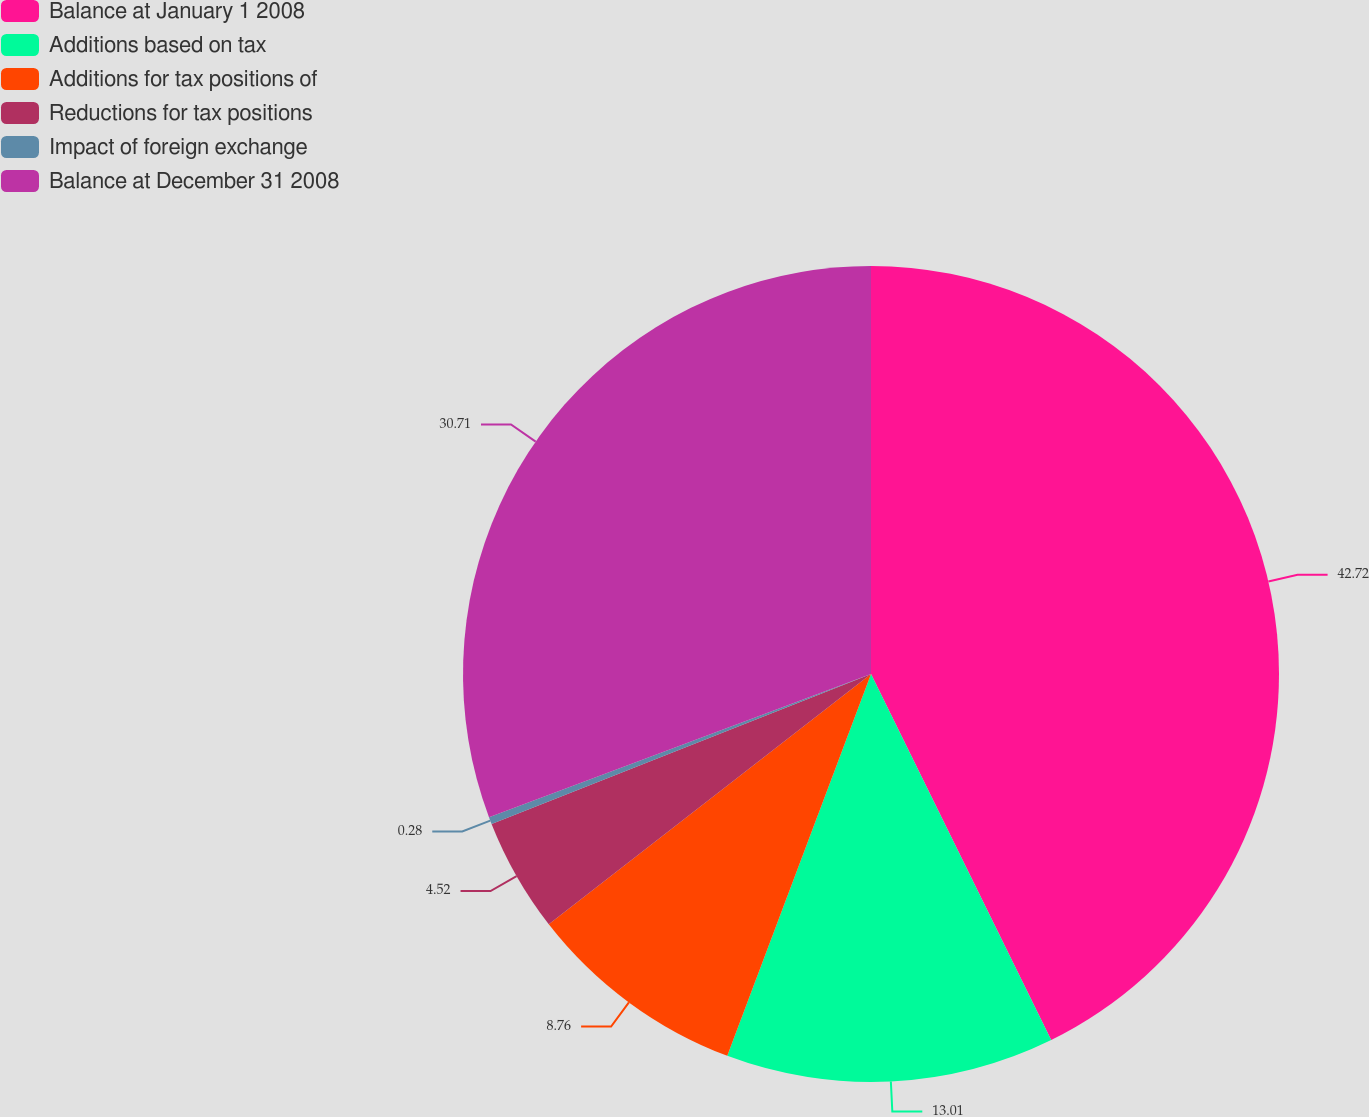<chart> <loc_0><loc_0><loc_500><loc_500><pie_chart><fcel>Balance at January 1 2008<fcel>Additions based on tax<fcel>Additions for tax positions of<fcel>Reductions for tax positions<fcel>Impact of foreign exchange<fcel>Balance at December 31 2008<nl><fcel>42.72%<fcel>13.01%<fcel>8.76%<fcel>4.52%<fcel>0.28%<fcel>30.71%<nl></chart> 